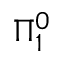Convert formula to latex. <formula><loc_0><loc_0><loc_500><loc_500>\Pi _ { 1 } ^ { 0 }</formula> 